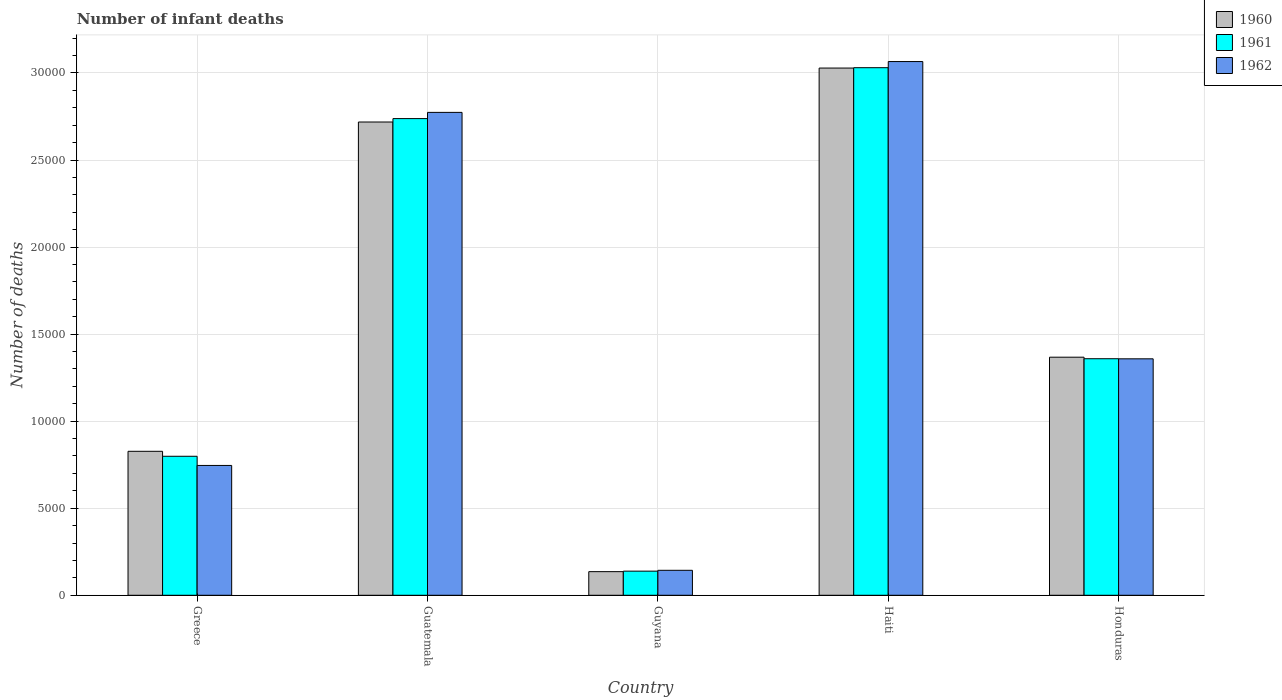How many different coloured bars are there?
Provide a short and direct response. 3. Are the number of bars on each tick of the X-axis equal?
Make the answer very short. Yes. What is the label of the 1st group of bars from the left?
Provide a succinct answer. Greece. What is the number of infant deaths in 1960 in Honduras?
Provide a succinct answer. 1.37e+04. Across all countries, what is the maximum number of infant deaths in 1960?
Ensure brevity in your answer.  3.03e+04. Across all countries, what is the minimum number of infant deaths in 1961?
Provide a succinct answer. 1386. In which country was the number of infant deaths in 1961 maximum?
Offer a very short reply. Haiti. In which country was the number of infant deaths in 1962 minimum?
Ensure brevity in your answer.  Guyana. What is the total number of infant deaths in 1961 in the graph?
Make the answer very short. 8.06e+04. What is the difference between the number of infant deaths in 1960 in Guyana and that in Haiti?
Your answer should be compact. -2.89e+04. What is the difference between the number of infant deaths in 1961 in Haiti and the number of infant deaths in 1960 in Greece?
Offer a very short reply. 2.20e+04. What is the average number of infant deaths in 1962 per country?
Offer a very short reply. 1.62e+04. What is the difference between the number of infant deaths of/in 1960 and number of infant deaths of/in 1962 in Guyana?
Keep it short and to the point. -77. In how many countries, is the number of infant deaths in 1961 greater than 2000?
Offer a very short reply. 4. What is the ratio of the number of infant deaths in 1962 in Greece to that in Haiti?
Make the answer very short. 0.24. Is the number of infant deaths in 1960 in Guatemala less than that in Haiti?
Give a very brief answer. Yes. What is the difference between the highest and the second highest number of infant deaths in 1960?
Offer a very short reply. 1.66e+04. What is the difference between the highest and the lowest number of infant deaths in 1961?
Give a very brief answer. 2.89e+04. In how many countries, is the number of infant deaths in 1962 greater than the average number of infant deaths in 1962 taken over all countries?
Provide a succinct answer. 2. Is the sum of the number of infant deaths in 1960 in Guyana and Honduras greater than the maximum number of infant deaths in 1962 across all countries?
Your response must be concise. No. What does the 2nd bar from the left in Honduras represents?
Offer a terse response. 1961. How many bars are there?
Offer a terse response. 15. Are the values on the major ticks of Y-axis written in scientific E-notation?
Make the answer very short. No. Does the graph contain any zero values?
Make the answer very short. No. Does the graph contain grids?
Your response must be concise. Yes. How many legend labels are there?
Your answer should be compact. 3. What is the title of the graph?
Ensure brevity in your answer.  Number of infant deaths. What is the label or title of the Y-axis?
Your answer should be very brief. Number of deaths. What is the Number of deaths of 1960 in Greece?
Your answer should be compact. 8269. What is the Number of deaths in 1961 in Greece?
Your answer should be very brief. 7984. What is the Number of deaths of 1962 in Greece?
Provide a succinct answer. 7457. What is the Number of deaths in 1960 in Guatemala?
Your answer should be compact. 2.72e+04. What is the Number of deaths in 1961 in Guatemala?
Your answer should be very brief. 2.74e+04. What is the Number of deaths in 1962 in Guatemala?
Your response must be concise. 2.77e+04. What is the Number of deaths in 1960 in Guyana?
Ensure brevity in your answer.  1357. What is the Number of deaths of 1961 in Guyana?
Make the answer very short. 1386. What is the Number of deaths in 1962 in Guyana?
Your response must be concise. 1434. What is the Number of deaths of 1960 in Haiti?
Your answer should be very brief. 3.03e+04. What is the Number of deaths in 1961 in Haiti?
Your answer should be very brief. 3.03e+04. What is the Number of deaths in 1962 in Haiti?
Your answer should be compact. 3.07e+04. What is the Number of deaths of 1960 in Honduras?
Offer a very short reply. 1.37e+04. What is the Number of deaths in 1961 in Honduras?
Provide a succinct answer. 1.36e+04. What is the Number of deaths of 1962 in Honduras?
Keep it short and to the point. 1.36e+04. Across all countries, what is the maximum Number of deaths in 1960?
Offer a very short reply. 3.03e+04. Across all countries, what is the maximum Number of deaths in 1961?
Provide a succinct answer. 3.03e+04. Across all countries, what is the maximum Number of deaths in 1962?
Provide a short and direct response. 3.07e+04. Across all countries, what is the minimum Number of deaths in 1960?
Give a very brief answer. 1357. Across all countries, what is the minimum Number of deaths in 1961?
Offer a very short reply. 1386. Across all countries, what is the minimum Number of deaths of 1962?
Make the answer very short. 1434. What is the total Number of deaths in 1960 in the graph?
Your answer should be compact. 8.08e+04. What is the total Number of deaths in 1961 in the graph?
Your answer should be very brief. 8.06e+04. What is the total Number of deaths of 1962 in the graph?
Offer a very short reply. 8.09e+04. What is the difference between the Number of deaths of 1960 in Greece and that in Guatemala?
Your answer should be very brief. -1.89e+04. What is the difference between the Number of deaths of 1961 in Greece and that in Guatemala?
Ensure brevity in your answer.  -1.94e+04. What is the difference between the Number of deaths of 1962 in Greece and that in Guatemala?
Give a very brief answer. -2.03e+04. What is the difference between the Number of deaths in 1960 in Greece and that in Guyana?
Provide a short and direct response. 6912. What is the difference between the Number of deaths of 1961 in Greece and that in Guyana?
Your answer should be compact. 6598. What is the difference between the Number of deaths in 1962 in Greece and that in Guyana?
Give a very brief answer. 6023. What is the difference between the Number of deaths of 1960 in Greece and that in Haiti?
Your answer should be very brief. -2.20e+04. What is the difference between the Number of deaths of 1961 in Greece and that in Haiti?
Give a very brief answer. -2.23e+04. What is the difference between the Number of deaths of 1962 in Greece and that in Haiti?
Your answer should be very brief. -2.32e+04. What is the difference between the Number of deaths in 1960 in Greece and that in Honduras?
Ensure brevity in your answer.  -5405. What is the difference between the Number of deaths of 1961 in Greece and that in Honduras?
Ensure brevity in your answer.  -5602. What is the difference between the Number of deaths in 1962 in Greece and that in Honduras?
Your response must be concise. -6124. What is the difference between the Number of deaths in 1960 in Guatemala and that in Guyana?
Provide a short and direct response. 2.58e+04. What is the difference between the Number of deaths of 1961 in Guatemala and that in Guyana?
Give a very brief answer. 2.60e+04. What is the difference between the Number of deaths of 1962 in Guatemala and that in Guyana?
Provide a short and direct response. 2.63e+04. What is the difference between the Number of deaths in 1960 in Guatemala and that in Haiti?
Your answer should be compact. -3099. What is the difference between the Number of deaths in 1961 in Guatemala and that in Haiti?
Provide a short and direct response. -2924. What is the difference between the Number of deaths in 1962 in Guatemala and that in Haiti?
Give a very brief answer. -2919. What is the difference between the Number of deaths in 1960 in Guatemala and that in Honduras?
Provide a short and direct response. 1.35e+04. What is the difference between the Number of deaths of 1961 in Guatemala and that in Honduras?
Offer a terse response. 1.38e+04. What is the difference between the Number of deaths of 1962 in Guatemala and that in Honduras?
Give a very brief answer. 1.42e+04. What is the difference between the Number of deaths of 1960 in Guyana and that in Haiti?
Provide a short and direct response. -2.89e+04. What is the difference between the Number of deaths in 1961 in Guyana and that in Haiti?
Provide a succinct answer. -2.89e+04. What is the difference between the Number of deaths of 1962 in Guyana and that in Haiti?
Your answer should be very brief. -2.92e+04. What is the difference between the Number of deaths in 1960 in Guyana and that in Honduras?
Keep it short and to the point. -1.23e+04. What is the difference between the Number of deaths in 1961 in Guyana and that in Honduras?
Give a very brief answer. -1.22e+04. What is the difference between the Number of deaths of 1962 in Guyana and that in Honduras?
Offer a very short reply. -1.21e+04. What is the difference between the Number of deaths in 1960 in Haiti and that in Honduras?
Your answer should be compact. 1.66e+04. What is the difference between the Number of deaths of 1961 in Haiti and that in Honduras?
Keep it short and to the point. 1.67e+04. What is the difference between the Number of deaths in 1962 in Haiti and that in Honduras?
Your response must be concise. 1.71e+04. What is the difference between the Number of deaths of 1960 in Greece and the Number of deaths of 1961 in Guatemala?
Your response must be concise. -1.91e+04. What is the difference between the Number of deaths in 1960 in Greece and the Number of deaths in 1962 in Guatemala?
Your answer should be very brief. -1.95e+04. What is the difference between the Number of deaths of 1961 in Greece and the Number of deaths of 1962 in Guatemala?
Make the answer very short. -1.98e+04. What is the difference between the Number of deaths in 1960 in Greece and the Number of deaths in 1961 in Guyana?
Provide a succinct answer. 6883. What is the difference between the Number of deaths of 1960 in Greece and the Number of deaths of 1962 in Guyana?
Make the answer very short. 6835. What is the difference between the Number of deaths of 1961 in Greece and the Number of deaths of 1962 in Guyana?
Your answer should be very brief. 6550. What is the difference between the Number of deaths of 1960 in Greece and the Number of deaths of 1961 in Haiti?
Your answer should be compact. -2.20e+04. What is the difference between the Number of deaths in 1960 in Greece and the Number of deaths in 1962 in Haiti?
Keep it short and to the point. -2.24e+04. What is the difference between the Number of deaths in 1961 in Greece and the Number of deaths in 1962 in Haiti?
Provide a short and direct response. -2.27e+04. What is the difference between the Number of deaths of 1960 in Greece and the Number of deaths of 1961 in Honduras?
Give a very brief answer. -5317. What is the difference between the Number of deaths in 1960 in Greece and the Number of deaths in 1962 in Honduras?
Keep it short and to the point. -5312. What is the difference between the Number of deaths of 1961 in Greece and the Number of deaths of 1962 in Honduras?
Offer a terse response. -5597. What is the difference between the Number of deaths in 1960 in Guatemala and the Number of deaths in 1961 in Guyana?
Keep it short and to the point. 2.58e+04. What is the difference between the Number of deaths in 1960 in Guatemala and the Number of deaths in 1962 in Guyana?
Ensure brevity in your answer.  2.57e+04. What is the difference between the Number of deaths in 1961 in Guatemala and the Number of deaths in 1962 in Guyana?
Your answer should be compact. 2.59e+04. What is the difference between the Number of deaths of 1960 in Guatemala and the Number of deaths of 1961 in Haiti?
Offer a very short reply. -3120. What is the difference between the Number of deaths in 1960 in Guatemala and the Number of deaths in 1962 in Haiti?
Your answer should be very brief. -3472. What is the difference between the Number of deaths of 1961 in Guatemala and the Number of deaths of 1962 in Haiti?
Provide a succinct answer. -3276. What is the difference between the Number of deaths of 1960 in Guatemala and the Number of deaths of 1961 in Honduras?
Your answer should be very brief. 1.36e+04. What is the difference between the Number of deaths of 1960 in Guatemala and the Number of deaths of 1962 in Honduras?
Your answer should be very brief. 1.36e+04. What is the difference between the Number of deaths of 1961 in Guatemala and the Number of deaths of 1962 in Honduras?
Provide a succinct answer. 1.38e+04. What is the difference between the Number of deaths of 1960 in Guyana and the Number of deaths of 1961 in Haiti?
Keep it short and to the point. -2.89e+04. What is the difference between the Number of deaths in 1960 in Guyana and the Number of deaths in 1962 in Haiti?
Ensure brevity in your answer.  -2.93e+04. What is the difference between the Number of deaths in 1961 in Guyana and the Number of deaths in 1962 in Haiti?
Your response must be concise. -2.93e+04. What is the difference between the Number of deaths in 1960 in Guyana and the Number of deaths in 1961 in Honduras?
Provide a succinct answer. -1.22e+04. What is the difference between the Number of deaths of 1960 in Guyana and the Number of deaths of 1962 in Honduras?
Provide a short and direct response. -1.22e+04. What is the difference between the Number of deaths of 1961 in Guyana and the Number of deaths of 1962 in Honduras?
Ensure brevity in your answer.  -1.22e+04. What is the difference between the Number of deaths in 1960 in Haiti and the Number of deaths in 1961 in Honduras?
Provide a short and direct response. 1.67e+04. What is the difference between the Number of deaths in 1960 in Haiti and the Number of deaths in 1962 in Honduras?
Your response must be concise. 1.67e+04. What is the difference between the Number of deaths in 1961 in Haiti and the Number of deaths in 1962 in Honduras?
Provide a short and direct response. 1.67e+04. What is the average Number of deaths of 1960 per country?
Your answer should be compact. 1.62e+04. What is the average Number of deaths of 1961 per country?
Your answer should be compact. 1.61e+04. What is the average Number of deaths in 1962 per country?
Your response must be concise. 1.62e+04. What is the difference between the Number of deaths in 1960 and Number of deaths in 1961 in Greece?
Give a very brief answer. 285. What is the difference between the Number of deaths of 1960 and Number of deaths of 1962 in Greece?
Your response must be concise. 812. What is the difference between the Number of deaths of 1961 and Number of deaths of 1962 in Greece?
Give a very brief answer. 527. What is the difference between the Number of deaths of 1960 and Number of deaths of 1961 in Guatemala?
Your answer should be compact. -196. What is the difference between the Number of deaths in 1960 and Number of deaths in 1962 in Guatemala?
Your response must be concise. -553. What is the difference between the Number of deaths in 1961 and Number of deaths in 1962 in Guatemala?
Give a very brief answer. -357. What is the difference between the Number of deaths of 1960 and Number of deaths of 1962 in Guyana?
Offer a terse response. -77. What is the difference between the Number of deaths of 1961 and Number of deaths of 1962 in Guyana?
Your answer should be compact. -48. What is the difference between the Number of deaths in 1960 and Number of deaths in 1961 in Haiti?
Offer a terse response. -21. What is the difference between the Number of deaths of 1960 and Number of deaths of 1962 in Haiti?
Ensure brevity in your answer.  -373. What is the difference between the Number of deaths of 1961 and Number of deaths of 1962 in Haiti?
Offer a very short reply. -352. What is the difference between the Number of deaths of 1960 and Number of deaths of 1961 in Honduras?
Your response must be concise. 88. What is the difference between the Number of deaths in 1960 and Number of deaths in 1962 in Honduras?
Provide a short and direct response. 93. What is the difference between the Number of deaths in 1961 and Number of deaths in 1962 in Honduras?
Provide a short and direct response. 5. What is the ratio of the Number of deaths of 1960 in Greece to that in Guatemala?
Your answer should be very brief. 0.3. What is the ratio of the Number of deaths of 1961 in Greece to that in Guatemala?
Your response must be concise. 0.29. What is the ratio of the Number of deaths of 1962 in Greece to that in Guatemala?
Give a very brief answer. 0.27. What is the ratio of the Number of deaths in 1960 in Greece to that in Guyana?
Offer a very short reply. 6.09. What is the ratio of the Number of deaths in 1961 in Greece to that in Guyana?
Your response must be concise. 5.76. What is the ratio of the Number of deaths of 1962 in Greece to that in Guyana?
Your response must be concise. 5.2. What is the ratio of the Number of deaths in 1960 in Greece to that in Haiti?
Your answer should be compact. 0.27. What is the ratio of the Number of deaths in 1961 in Greece to that in Haiti?
Make the answer very short. 0.26. What is the ratio of the Number of deaths in 1962 in Greece to that in Haiti?
Offer a very short reply. 0.24. What is the ratio of the Number of deaths of 1960 in Greece to that in Honduras?
Ensure brevity in your answer.  0.6. What is the ratio of the Number of deaths in 1961 in Greece to that in Honduras?
Keep it short and to the point. 0.59. What is the ratio of the Number of deaths in 1962 in Greece to that in Honduras?
Provide a short and direct response. 0.55. What is the ratio of the Number of deaths in 1960 in Guatemala to that in Guyana?
Provide a short and direct response. 20.03. What is the ratio of the Number of deaths of 1961 in Guatemala to that in Guyana?
Make the answer very short. 19.75. What is the ratio of the Number of deaths in 1962 in Guatemala to that in Guyana?
Give a very brief answer. 19.34. What is the ratio of the Number of deaths in 1960 in Guatemala to that in Haiti?
Provide a short and direct response. 0.9. What is the ratio of the Number of deaths of 1961 in Guatemala to that in Haiti?
Provide a succinct answer. 0.9. What is the ratio of the Number of deaths in 1962 in Guatemala to that in Haiti?
Keep it short and to the point. 0.9. What is the ratio of the Number of deaths in 1960 in Guatemala to that in Honduras?
Your answer should be compact. 1.99. What is the ratio of the Number of deaths in 1961 in Guatemala to that in Honduras?
Make the answer very short. 2.02. What is the ratio of the Number of deaths in 1962 in Guatemala to that in Honduras?
Offer a terse response. 2.04. What is the ratio of the Number of deaths of 1960 in Guyana to that in Haiti?
Offer a terse response. 0.04. What is the ratio of the Number of deaths in 1961 in Guyana to that in Haiti?
Your response must be concise. 0.05. What is the ratio of the Number of deaths of 1962 in Guyana to that in Haiti?
Provide a short and direct response. 0.05. What is the ratio of the Number of deaths of 1960 in Guyana to that in Honduras?
Keep it short and to the point. 0.1. What is the ratio of the Number of deaths of 1961 in Guyana to that in Honduras?
Ensure brevity in your answer.  0.1. What is the ratio of the Number of deaths in 1962 in Guyana to that in Honduras?
Ensure brevity in your answer.  0.11. What is the ratio of the Number of deaths of 1960 in Haiti to that in Honduras?
Ensure brevity in your answer.  2.21. What is the ratio of the Number of deaths of 1961 in Haiti to that in Honduras?
Your response must be concise. 2.23. What is the ratio of the Number of deaths in 1962 in Haiti to that in Honduras?
Offer a terse response. 2.26. What is the difference between the highest and the second highest Number of deaths in 1960?
Offer a very short reply. 3099. What is the difference between the highest and the second highest Number of deaths in 1961?
Make the answer very short. 2924. What is the difference between the highest and the second highest Number of deaths in 1962?
Your answer should be very brief. 2919. What is the difference between the highest and the lowest Number of deaths in 1960?
Make the answer very short. 2.89e+04. What is the difference between the highest and the lowest Number of deaths in 1961?
Offer a very short reply. 2.89e+04. What is the difference between the highest and the lowest Number of deaths of 1962?
Offer a terse response. 2.92e+04. 